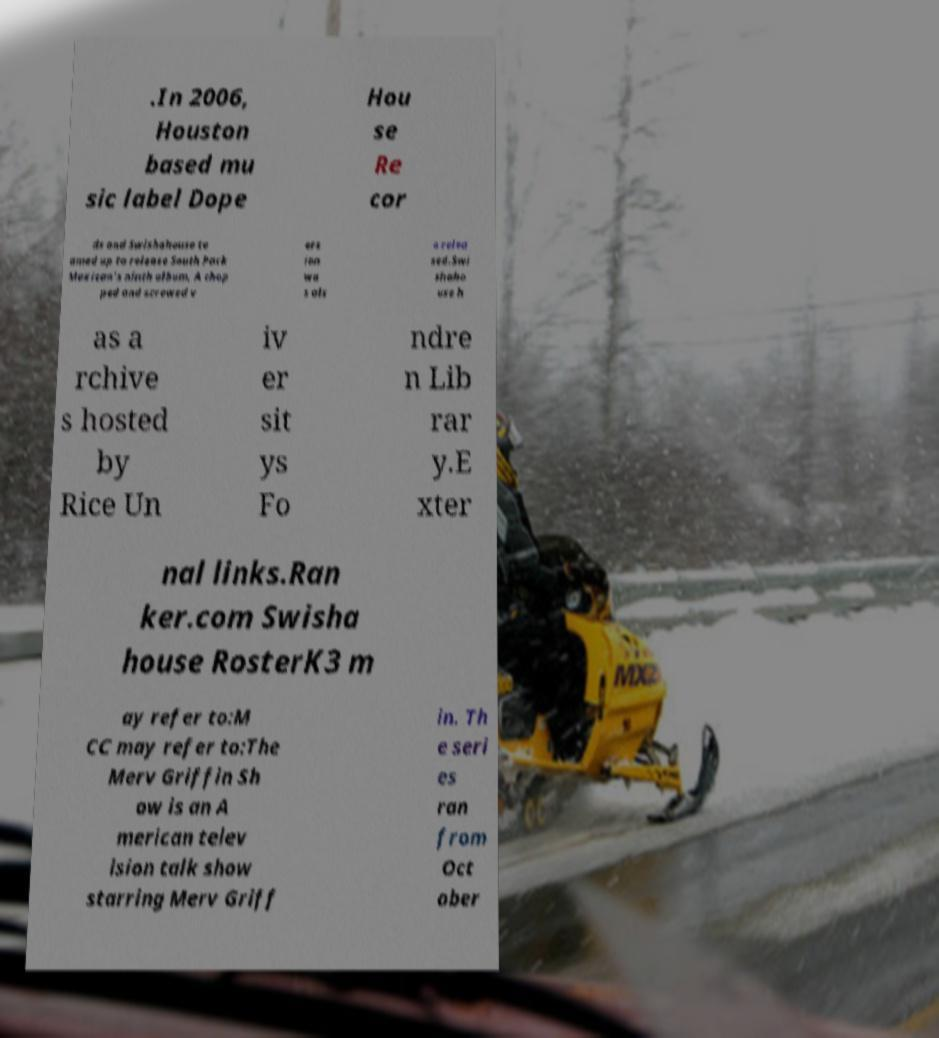Please identify and transcribe the text found in this image. .In 2006, Houston based mu sic label Dope Hou se Re cor ds and Swishahouse te amed up to release South Park Mexican's ninth album, A chop ped and screwed v ers ion wa s als o relea sed.Swi shaho use h as a rchive s hosted by Rice Un iv er sit ys Fo ndre n Lib rar y.E xter nal links.Ran ker.com Swisha house RosterK3 m ay refer to:M CC may refer to:The Merv Griffin Sh ow is an A merican telev ision talk show starring Merv Griff in. Th e seri es ran from Oct ober 